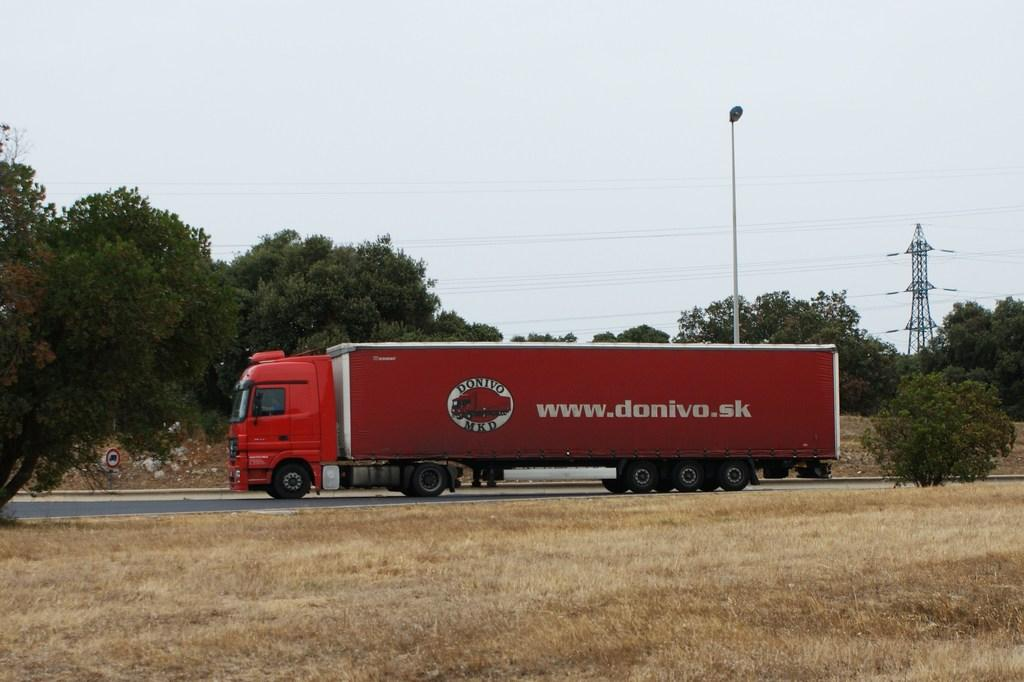What is on the road in the image? There is a vehicle on the road in the image. What can be seen beside the road? There is dry grass and a tree beside the road. What is visible in the background of the image? There are trees, a light pole, and a tower with wires in the background of the image. Can you see any rabbits requesting gold in the image? There are no rabbits or requests for gold present in the image. 